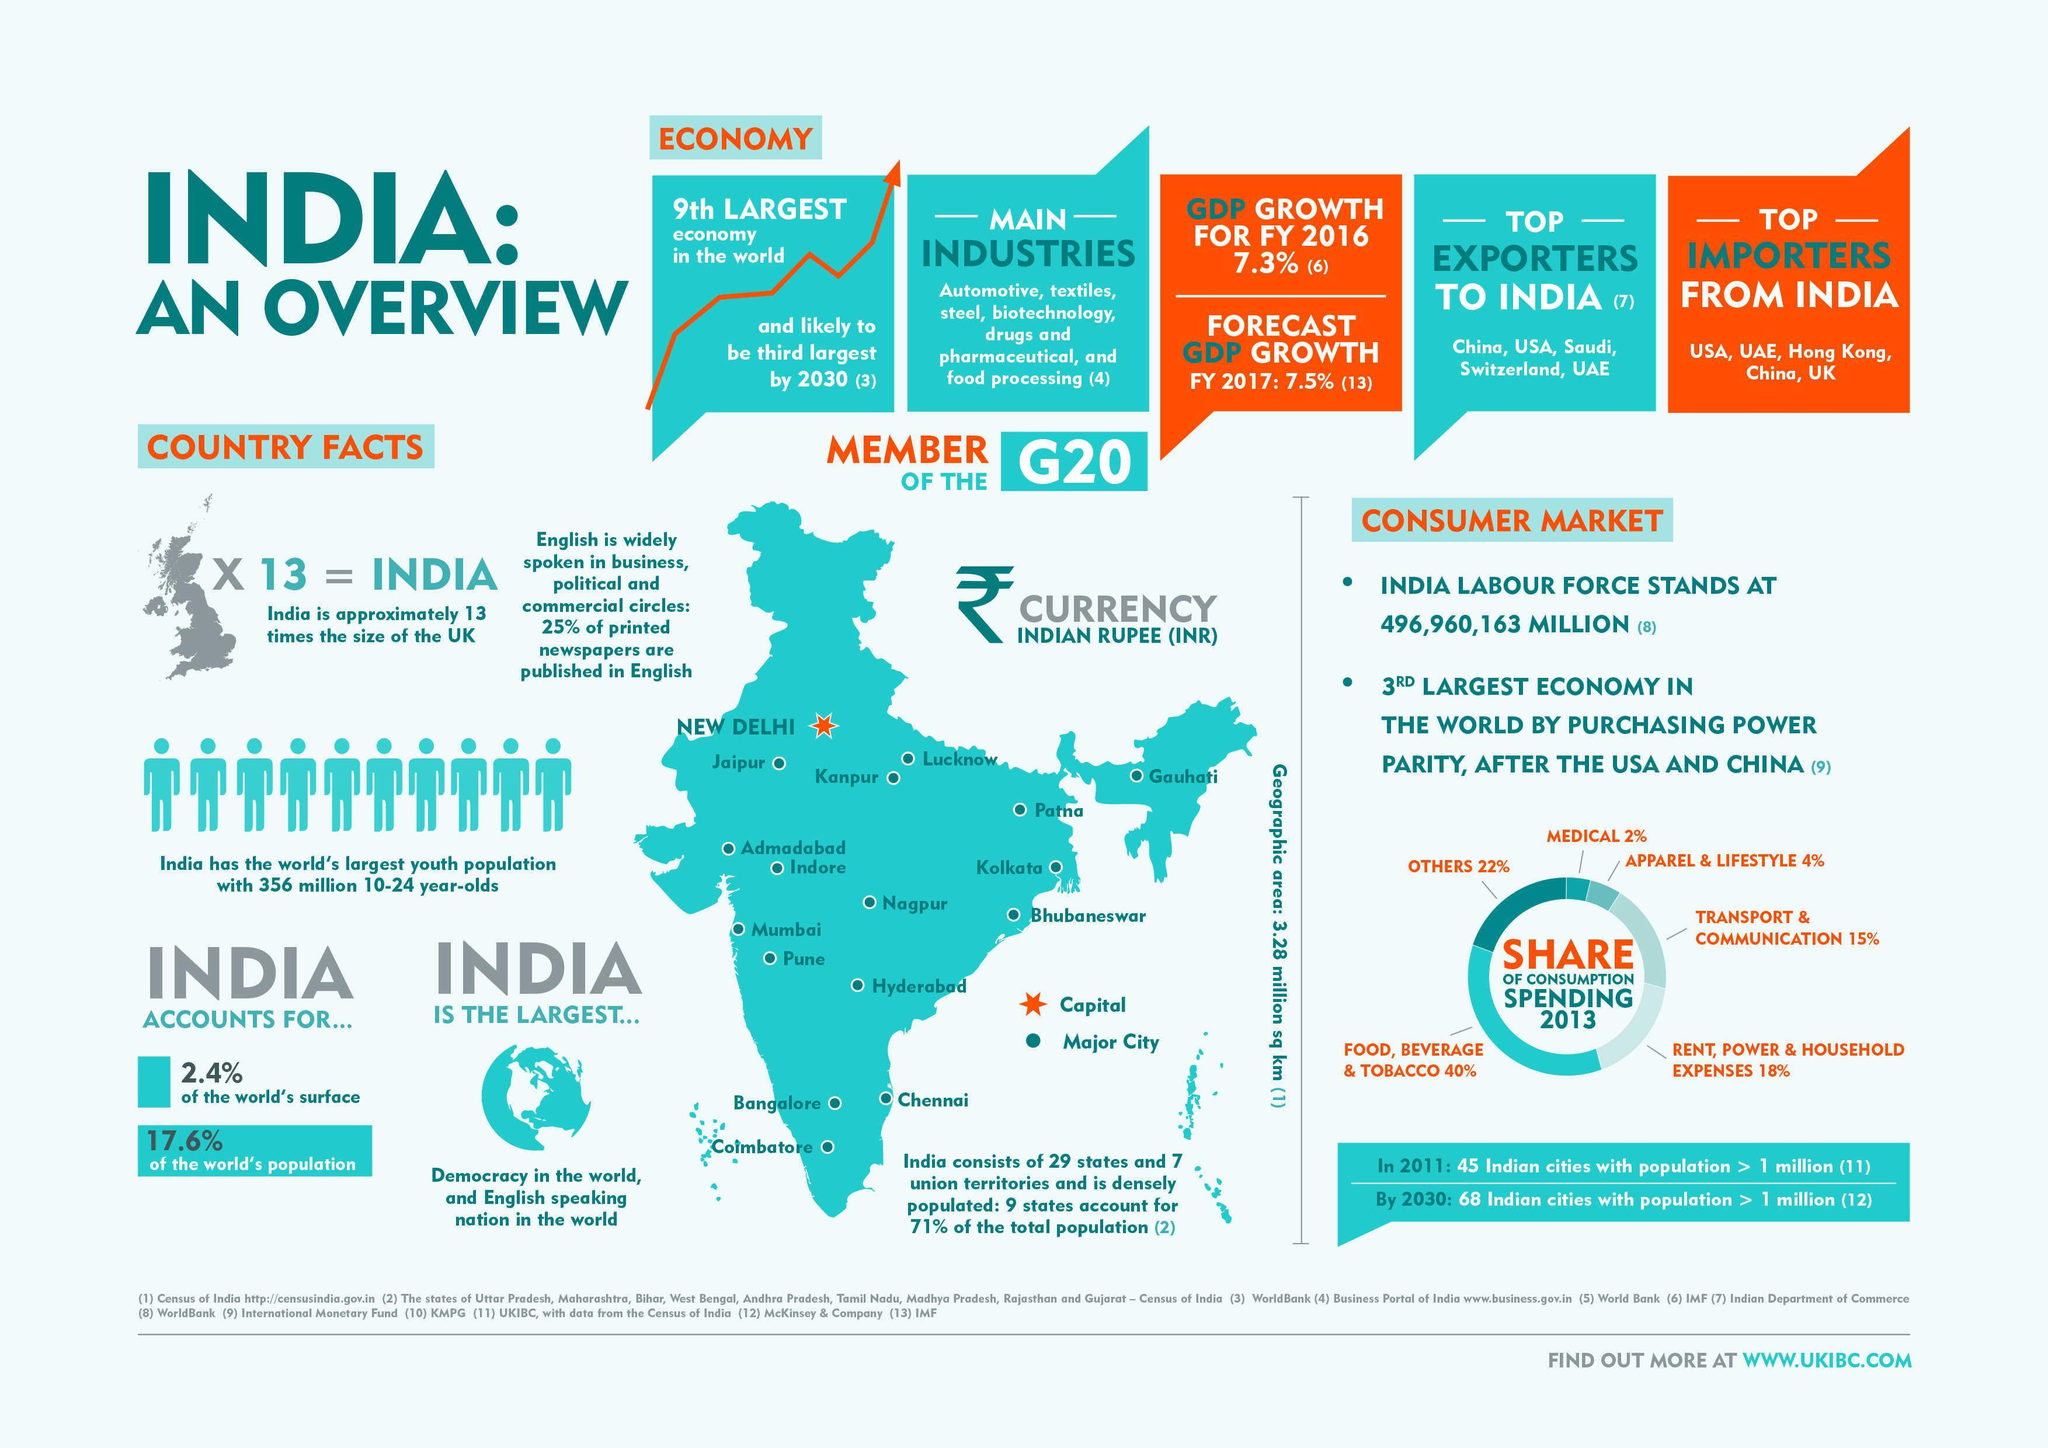Which is the capital city of India?
Answer the question with a short phrase. NEW DELHI What is the percentage share of consumption spending in transportation & communication industry in India in 2013? 15% What is the percentage share of consumption spending in medical industry in India in 2013? 2% 